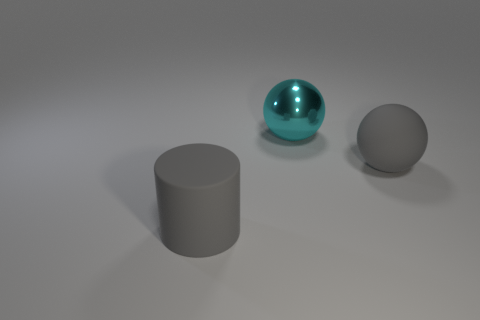Subtract all cyan balls. How many balls are left? 1 Subtract all spheres. How many objects are left? 1 Subtract 1 cylinders. How many cylinders are left? 0 Add 2 gray metal spheres. How many objects exist? 5 Subtract all brown cylinders. How many purple balls are left? 0 Add 1 tiny red balls. How many tiny red balls exist? 1 Subtract 0 gray cubes. How many objects are left? 3 Subtract all cyan balls. Subtract all gray blocks. How many balls are left? 1 Subtract all cyan shiny things. Subtract all large cylinders. How many objects are left? 1 Add 1 big gray rubber balls. How many big gray rubber balls are left? 2 